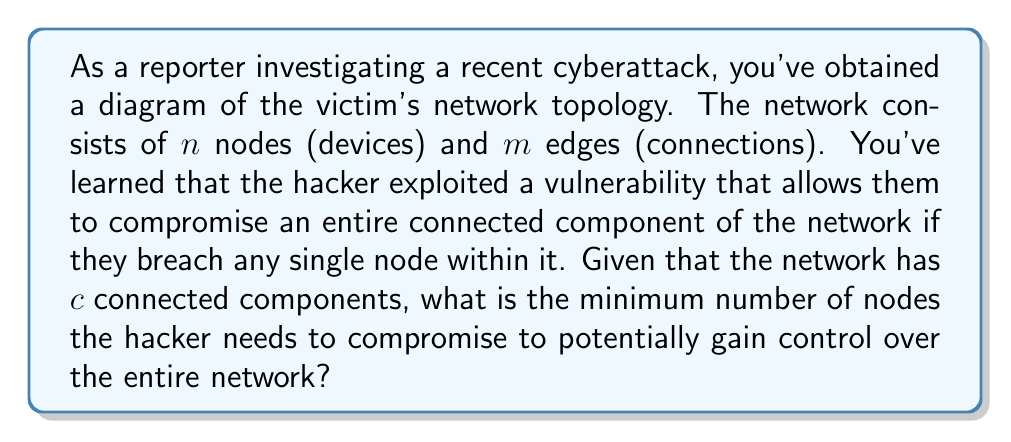Could you help me with this problem? To solve this problem, we need to understand the concept of connected components in graph theory and how it relates to network topology:

1. A connected component is a subgraph in which any two vertices are connected to each other by paths, and which is connected to no additional vertices in the supergraph.

2. In the context of a cybersecurity defense network, each connected component represents a group of devices that can communicate with each other, but not with devices in other components.

3. The hacker's exploit allows them to compromise an entire connected component by breaching just one node within it.

4. To gain control over the entire network, the hacker needs to compromise at least one node in each connected component.

5. The minimum number of nodes the hacker needs to compromise is equal to the number of connected components, $c$.

This is because:
- Each connected component must be compromised independently.
- Compromising one node in a component is sufficient to control that entire component.
- There are $c$ components in total.

Therefore, by compromising exactly $c$ nodes (one from each component), the hacker can potentially control the entire network.

It's worth noting that this represents the theoretical minimum. In practice, the actual number might be higher depending on the specific network structure and the hacker's access points.
Answer: $c$ nodes 